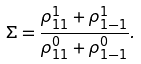<formula> <loc_0><loc_0><loc_500><loc_500>\Sigma = \frac { \rho ^ { 1 } _ { 1 1 } + \rho ^ { 1 } _ { 1 - 1 } } { \rho ^ { 0 } _ { 1 1 } + \rho ^ { 0 } _ { 1 - 1 } } .</formula> 